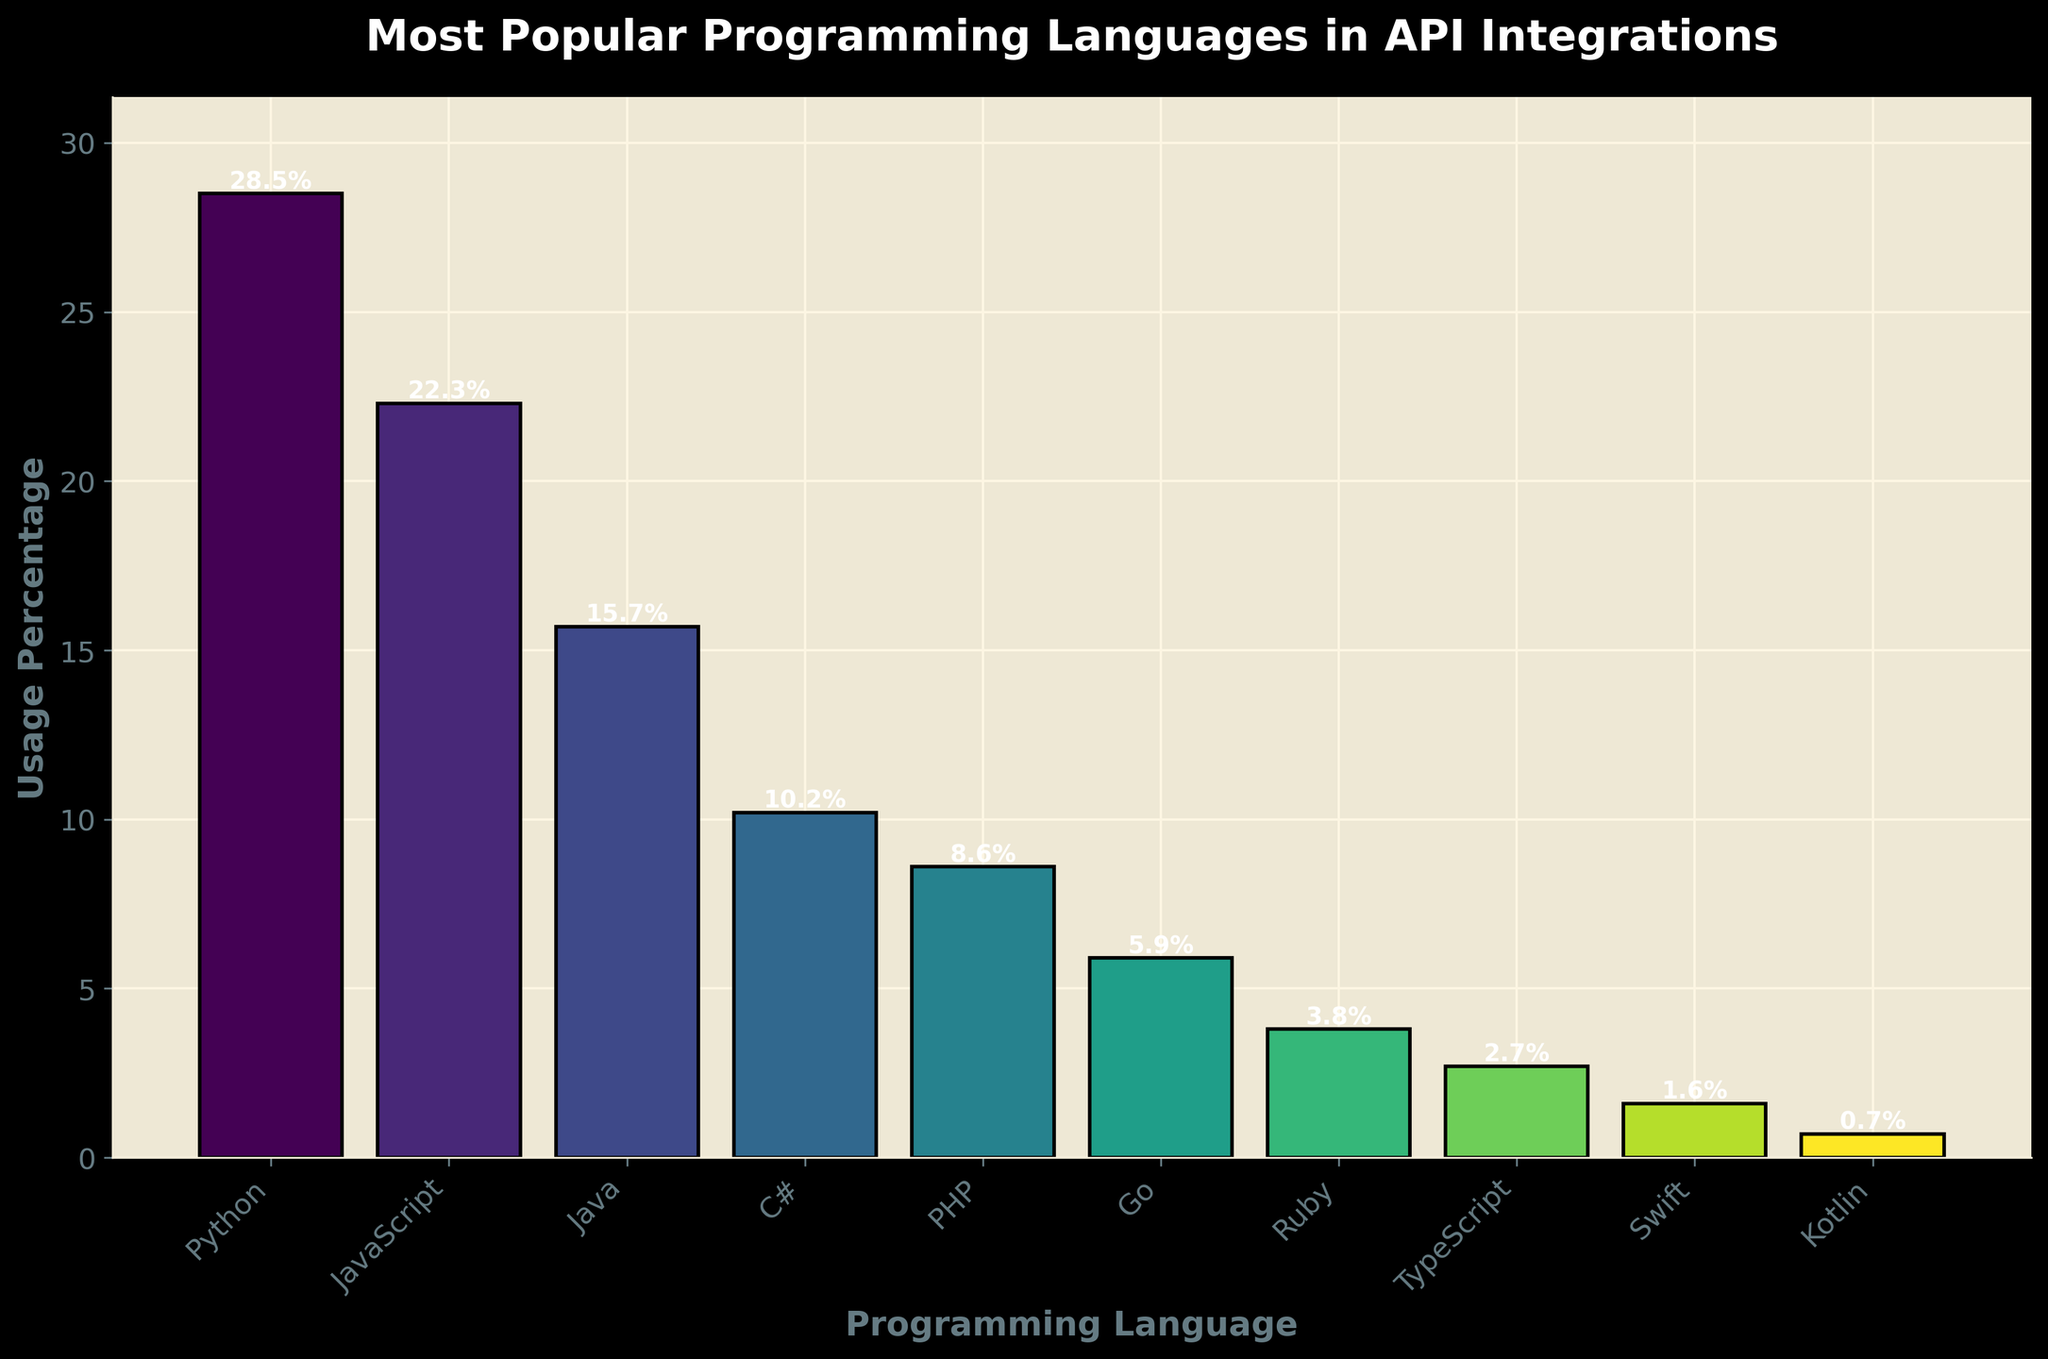Which programming language has the highest usage percentage? The bar representing Python is the tallest, indicating it has the highest usage percentage.
Answer: Python What is the difference in usage percentage between Python and JavaScript? Python has a usage of 28.5%, and JavaScript has a usage of 22.3%. The difference is calculated as 28.5% - 22.3% = 6.2%.
Answer: 6.2% How many programming languages have a usage percentage greater than 10%? By looking at the bars, the languages with usage percentages greater than 10% are Python, JavaScript, Java, and C#. So, there are 4 languages.
Answer: 4 Which language has the lowest usage percentage, and what is its value? The bar representing Kotlin is the shortest, indicating it has the lowest usage percentage of 0.7%.
Answer: Kotlin, 0.7% Is the usage percentage of PHP closer to that of C# or Go? PHP has a usage percentage of 8.6%. C# has a usage percentage of 10.2%, and Go has a usage percentage of 5.9%. The difference between PHP and C# is 1.6%, and the difference between PHP and Go is 2.7%. Thus, PHP is closer to C#.
Answer: C# Calculate the average usage percentage of the top three most popular languages. The top three languages by usage are Python (28.5%), JavaScript (22.3%), and Java (15.7%). The average is calculated as (28.5% + 22.3% + 15.7%) / 3 ≈ 22.17%.
Answer: 22.17% What is the combined usage percentage of all languages with a usage percentage below 5%? The languages with usage percentages below 5% are Ruby, TypeScript, Swift, and Kotlin. Their sums are 3.8% + 2.7% + 1.6% + 0.7% = 8.8%.
Answer: 8.8% How does the visual height of the Python bar compare to that of PHP? Visually, the bar for Python is significantly taller than the bar for PHP, indicating Python's higher usage percentage of 28.5% compared to PHP's 8.6%.
Answer: Python's bar is significantly taller What is the range of usage percentages among the languages? The range is calculated by subtracting the lowest usage percentage (Kotlin at 0.7%) from the highest usage percentage (Python at 28.5%). So, the range is 28.5% - 0.7% = 27.8%.
Answer: 27.8% 